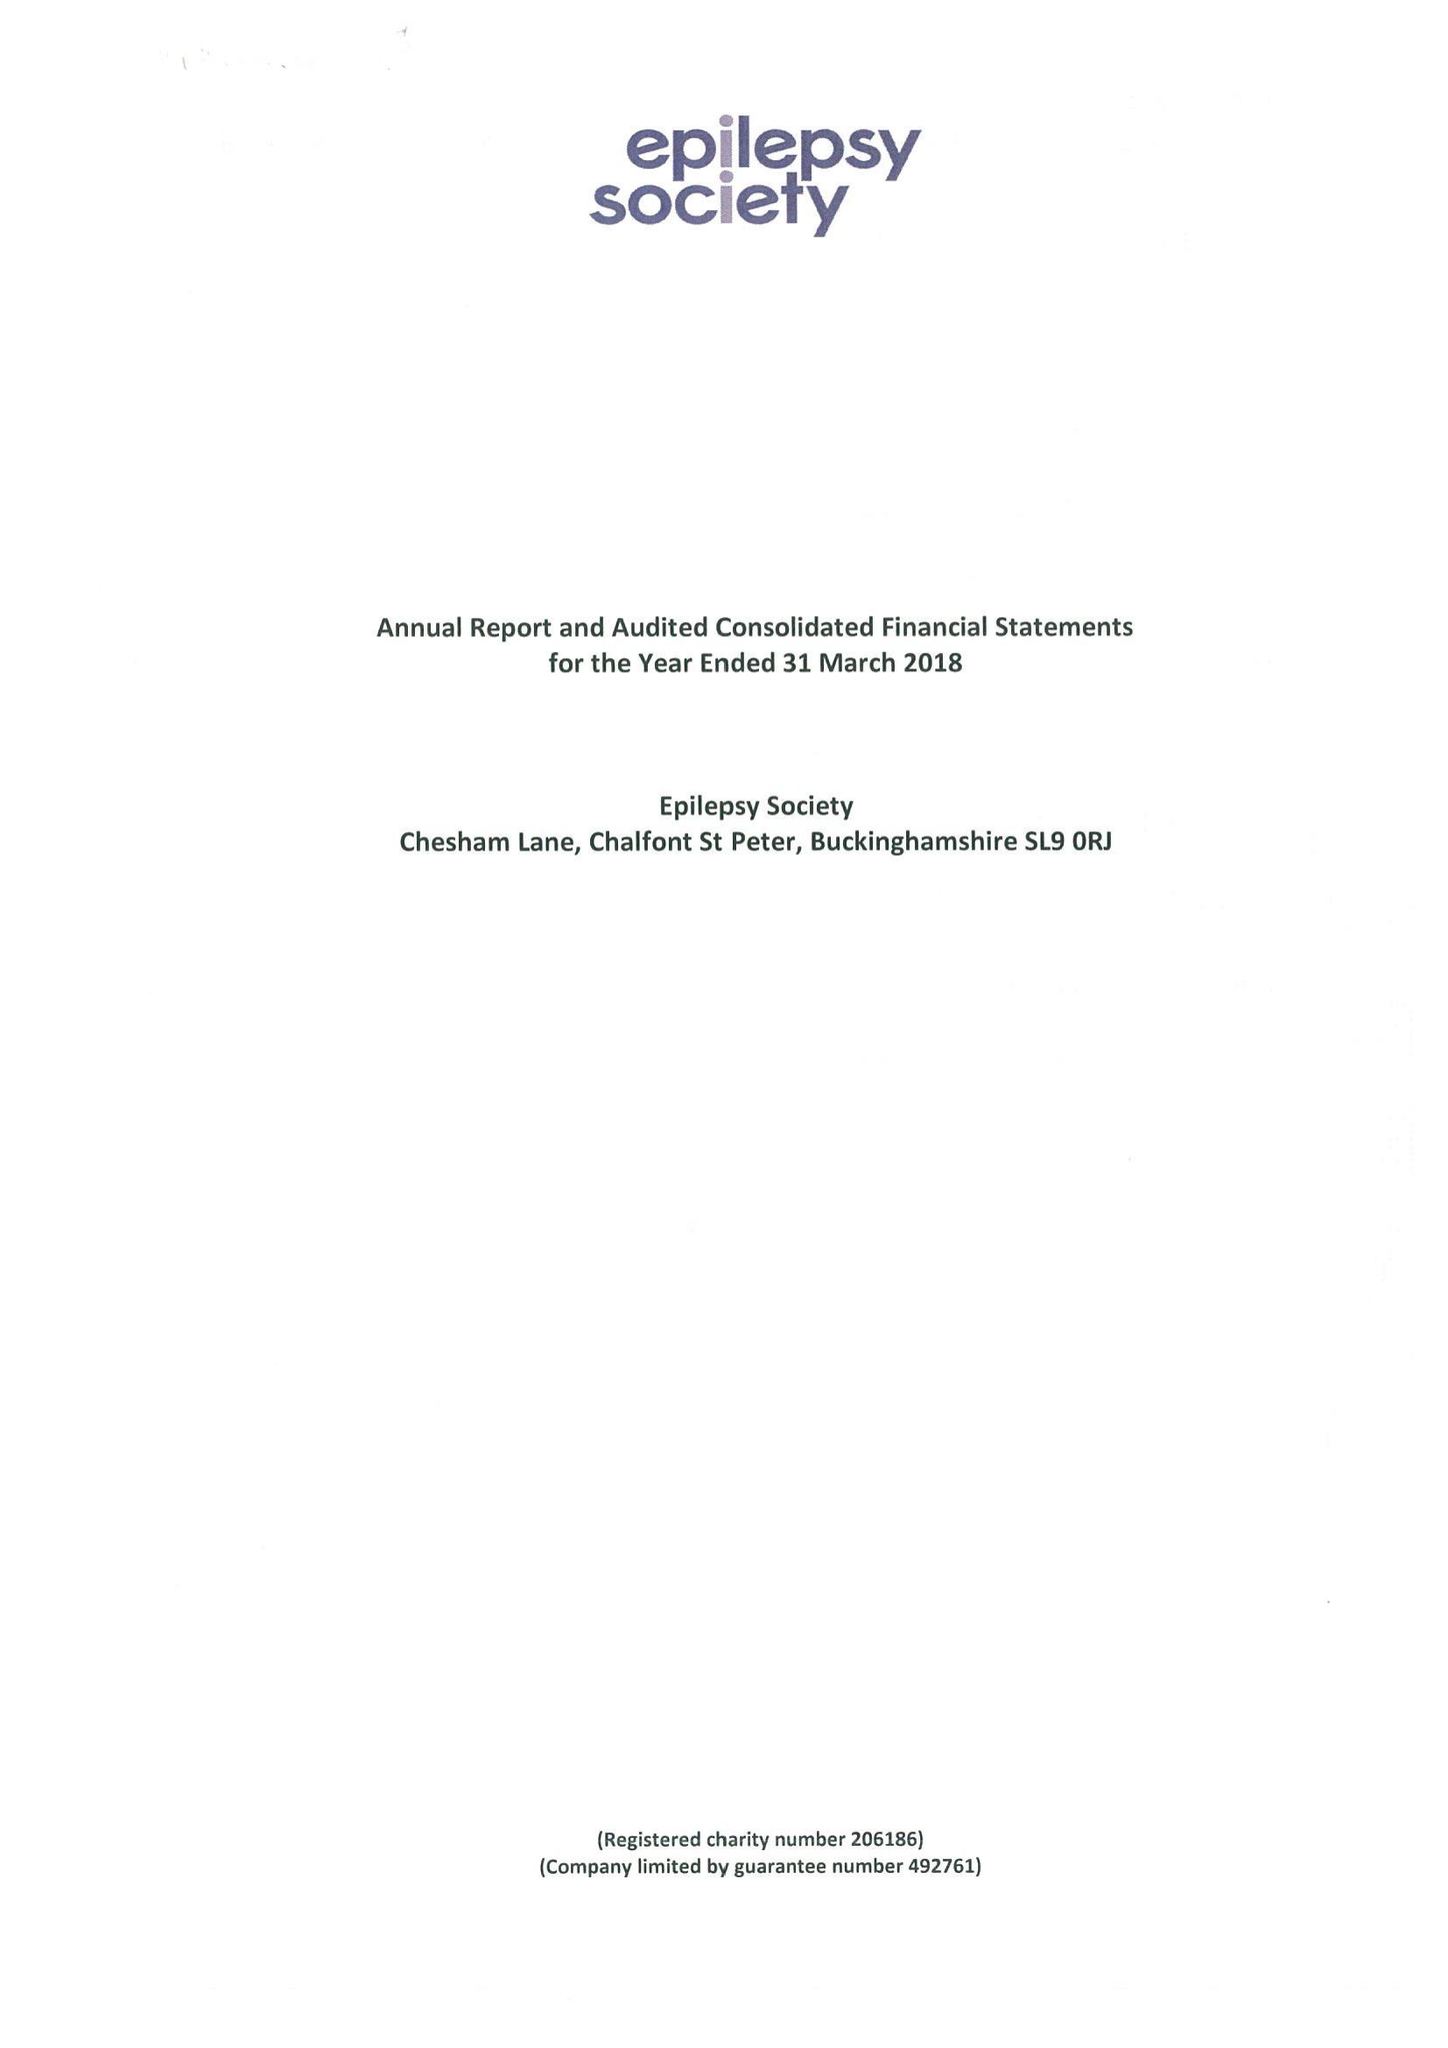What is the value for the spending_annually_in_british_pounds?
Answer the question using a single word or phrase. 17045000.00 